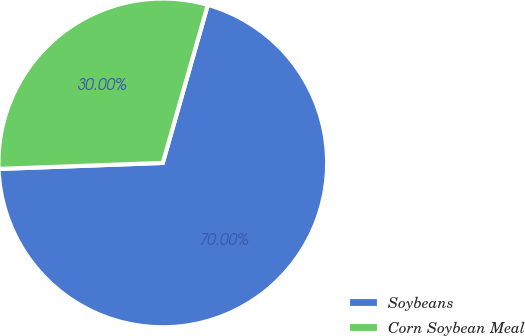Convert chart. <chart><loc_0><loc_0><loc_500><loc_500><pie_chart><fcel>Soybeans<fcel>Corn Soybean Meal<nl><fcel>70.0%<fcel>30.0%<nl></chart> 